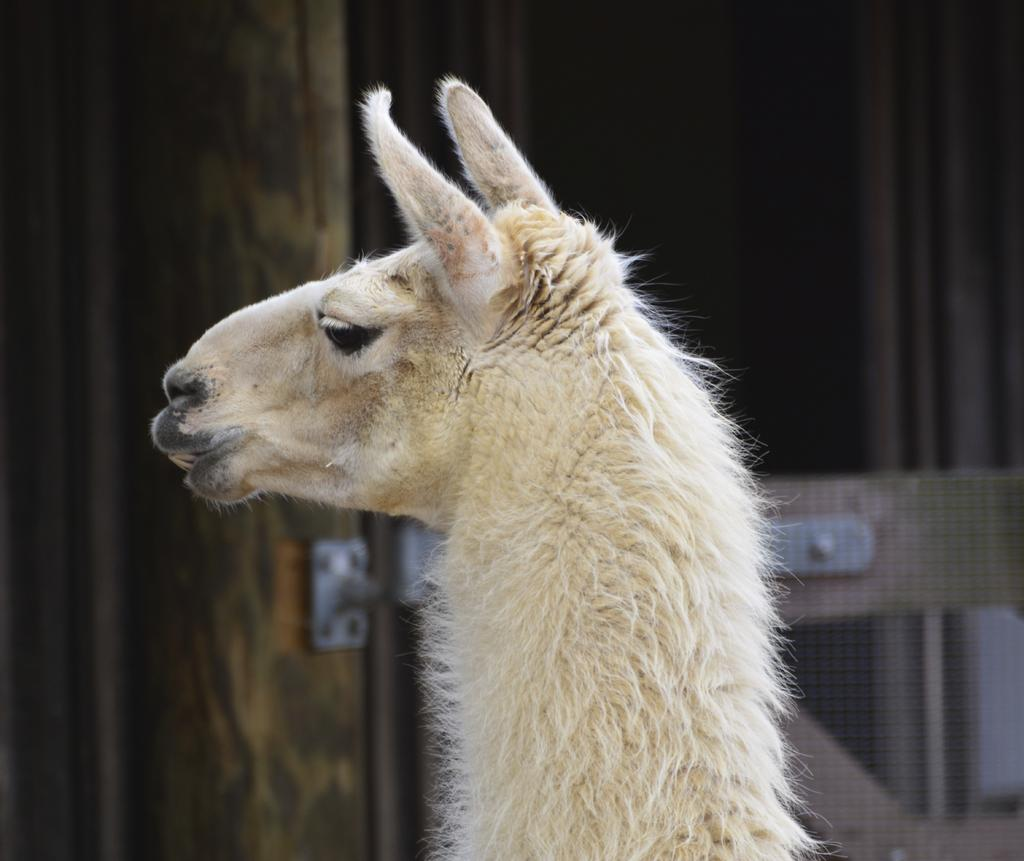What is the main subject of the image? The main subject of the image is an animal face and neck. Can you describe the background of the image? The background of the image is blurry. How many additions can be seen in the image? There are no additions present in the image; it features an animal face and neck with a blurry background. What type of air is visible in the image? There is no air visible in the image; it is a two-dimensional representation of an animal face and neck with a blurry background. 